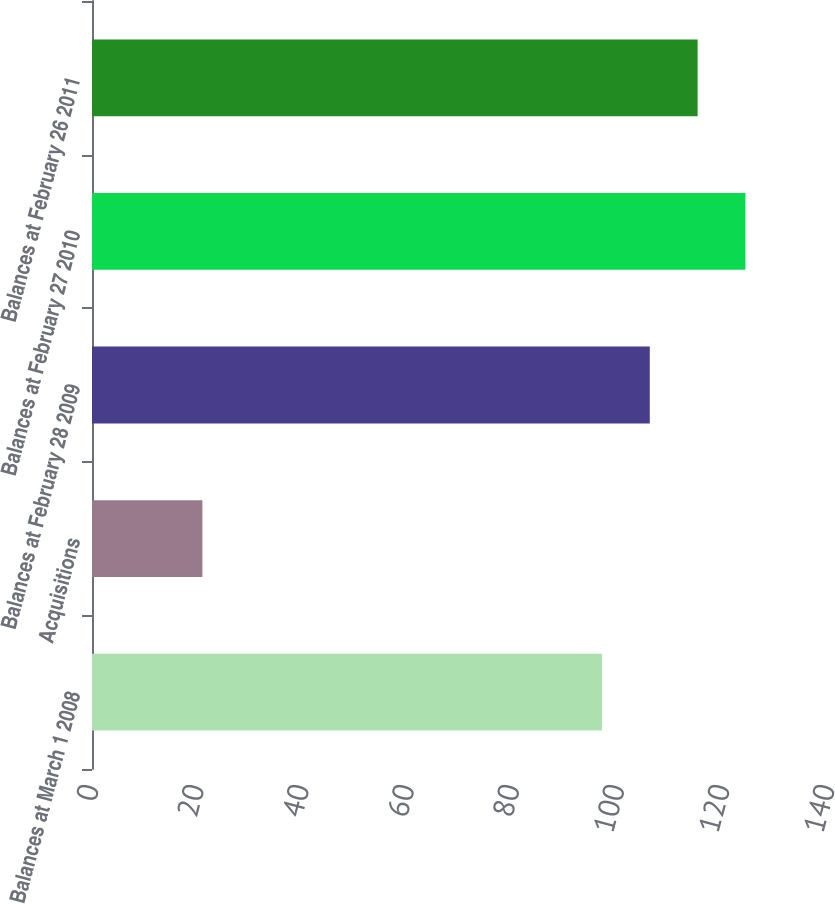Convert chart to OTSL. <chart><loc_0><loc_0><loc_500><loc_500><bar_chart><fcel>Balances at March 1 2008<fcel>Acquisitions<fcel>Balances at February 28 2009<fcel>Balances at February 27 2010<fcel>Balances at February 26 2011<nl><fcel>97<fcel>21<fcel>106.1<fcel>124.3<fcel>115.2<nl></chart> 